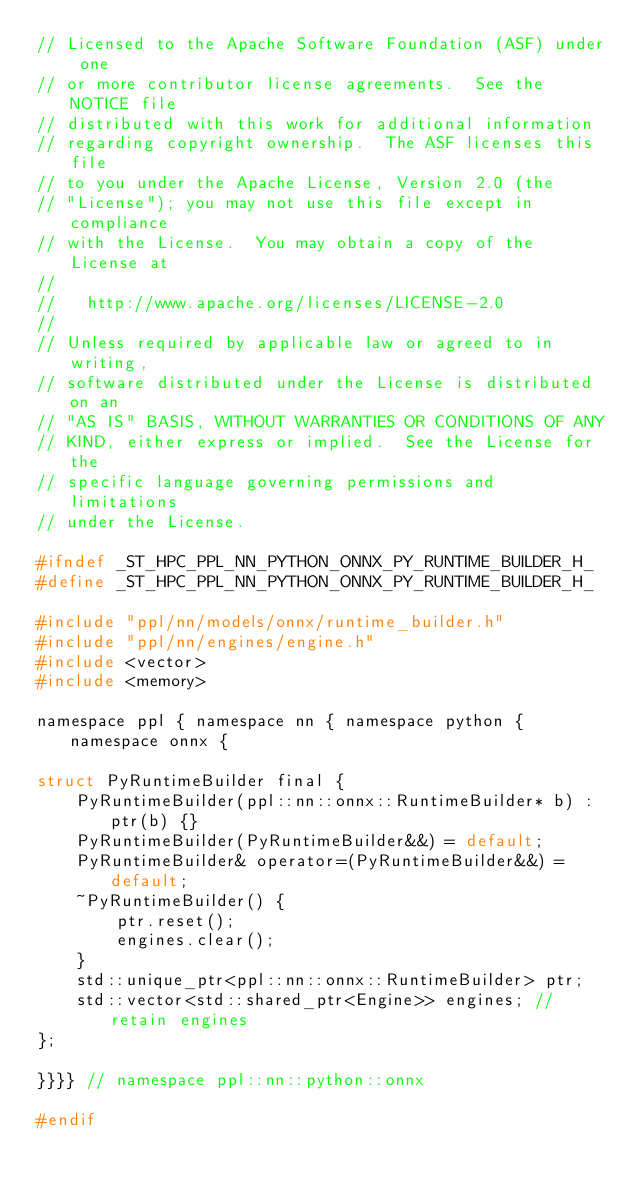<code> <loc_0><loc_0><loc_500><loc_500><_C_>// Licensed to the Apache Software Foundation (ASF) under one
// or more contributor license agreements.  See the NOTICE file
// distributed with this work for additional information
// regarding copyright ownership.  The ASF licenses this file
// to you under the Apache License, Version 2.0 (the
// "License"); you may not use this file except in compliance
// with the License.  You may obtain a copy of the License at
//
//   http://www.apache.org/licenses/LICENSE-2.0
//
// Unless required by applicable law or agreed to in writing,
// software distributed under the License is distributed on an
// "AS IS" BASIS, WITHOUT WARRANTIES OR CONDITIONS OF ANY
// KIND, either express or implied.  See the License for the
// specific language governing permissions and limitations
// under the License.

#ifndef _ST_HPC_PPL_NN_PYTHON_ONNX_PY_RUNTIME_BUILDER_H_
#define _ST_HPC_PPL_NN_PYTHON_ONNX_PY_RUNTIME_BUILDER_H_

#include "ppl/nn/models/onnx/runtime_builder.h"
#include "ppl/nn/engines/engine.h"
#include <vector>
#include <memory>

namespace ppl { namespace nn { namespace python { namespace onnx {

struct PyRuntimeBuilder final {
    PyRuntimeBuilder(ppl::nn::onnx::RuntimeBuilder* b) : ptr(b) {}
    PyRuntimeBuilder(PyRuntimeBuilder&&) = default;
    PyRuntimeBuilder& operator=(PyRuntimeBuilder&&) = default;
    ~PyRuntimeBuilder() {
        ptr.reset();
        engines.clear();
    }
    std::unique_ptr<ppl::nn::onnx::RuntimeBuilder> ptr;
    std::vector<std::shared_ptr<Engine>> engines; // retain engines
};

}}}} // namespace ppl::nn::python::onnx

#endif
</code> 